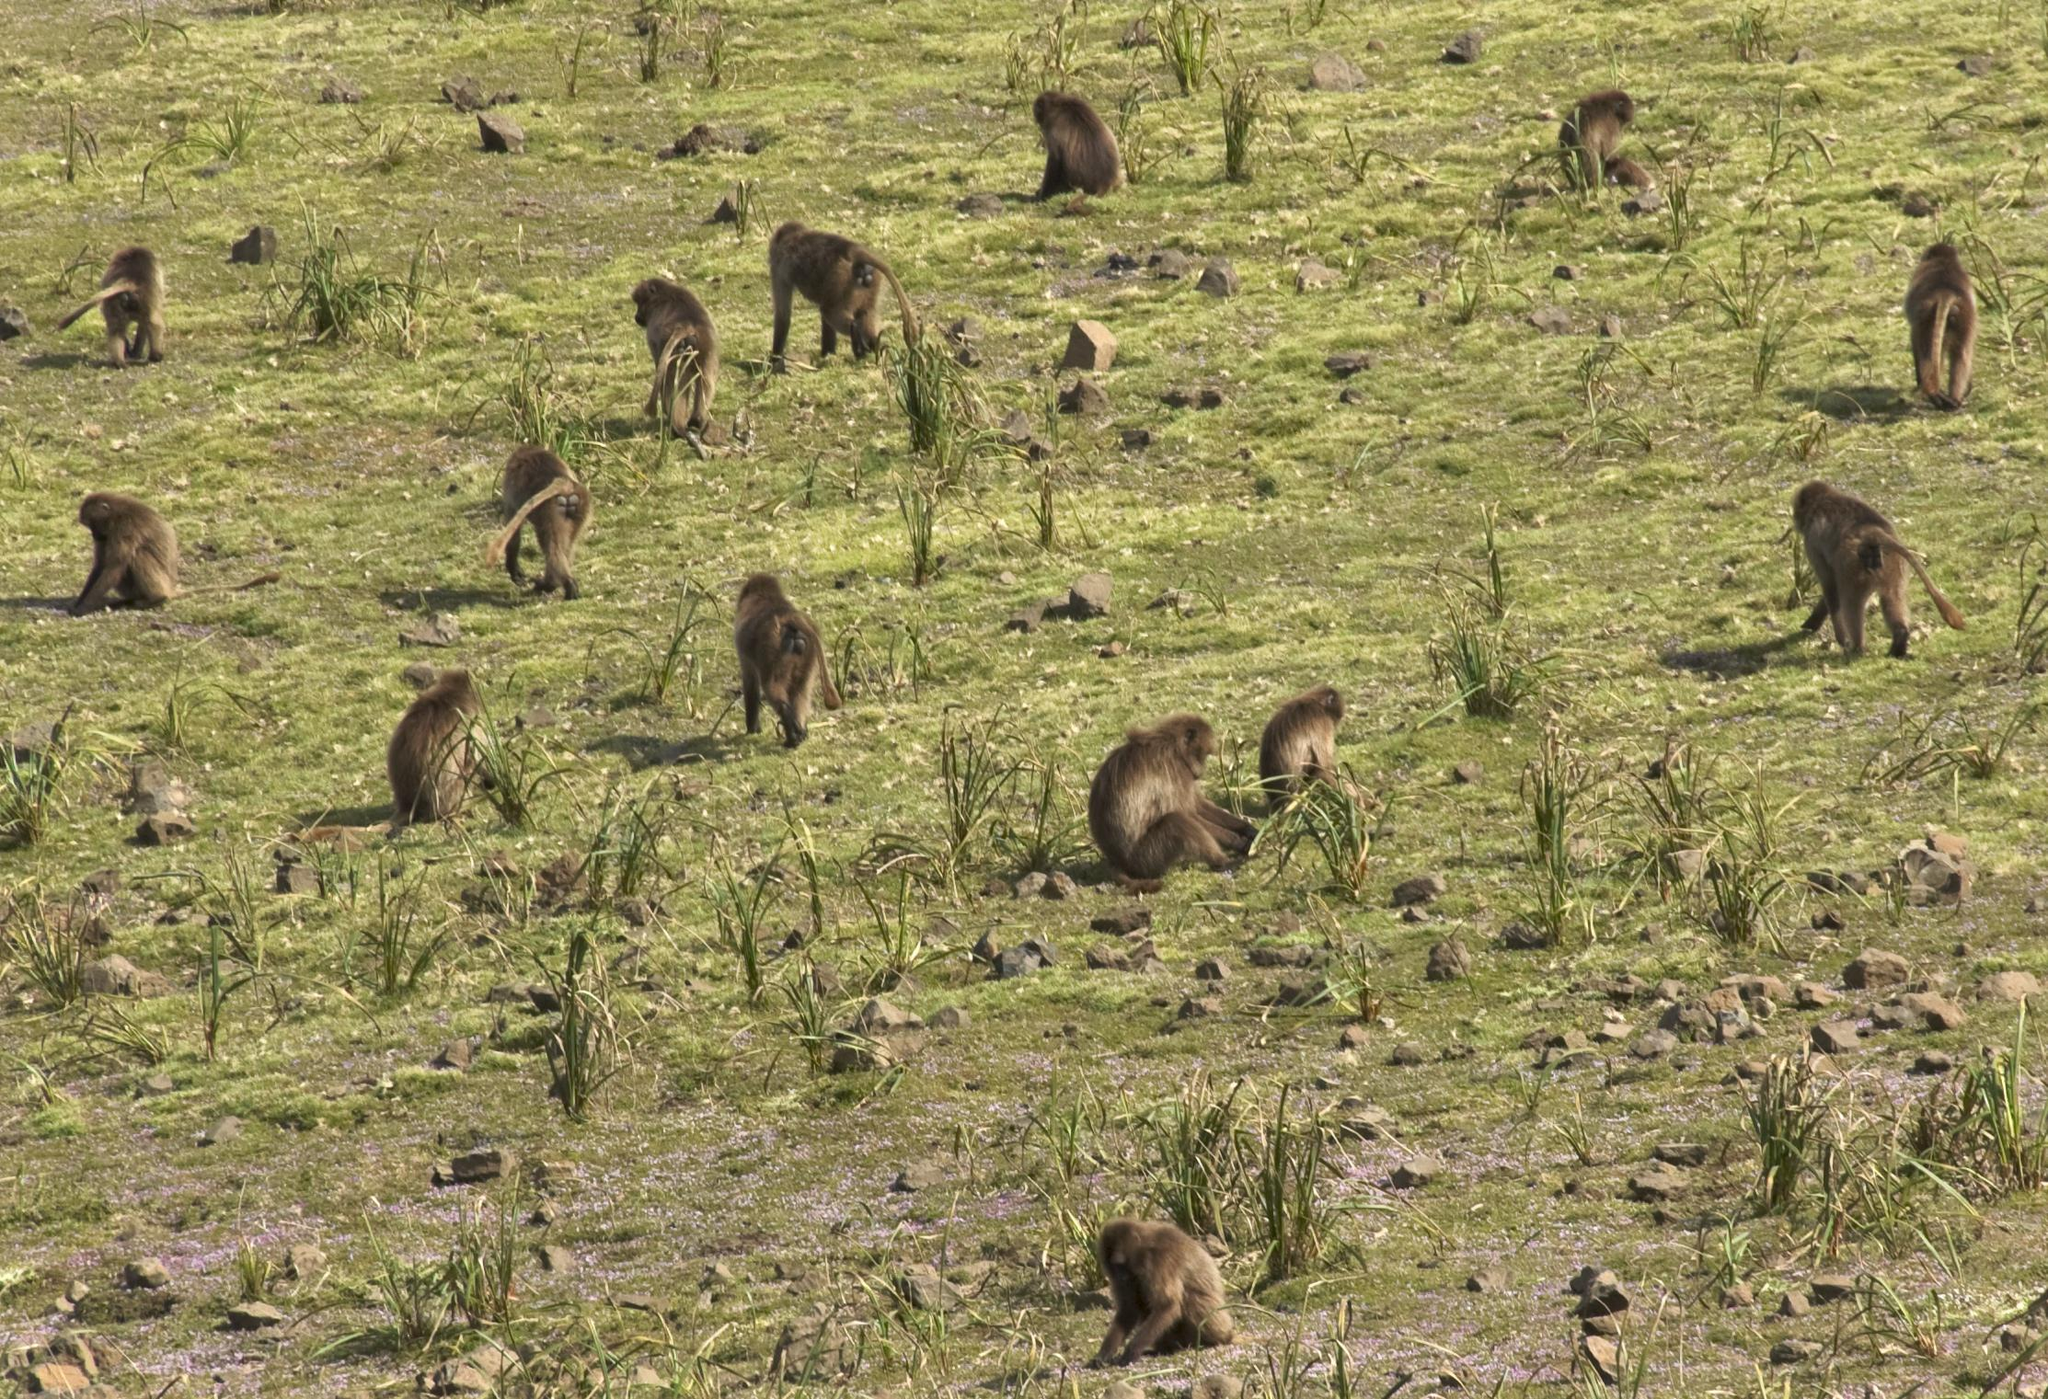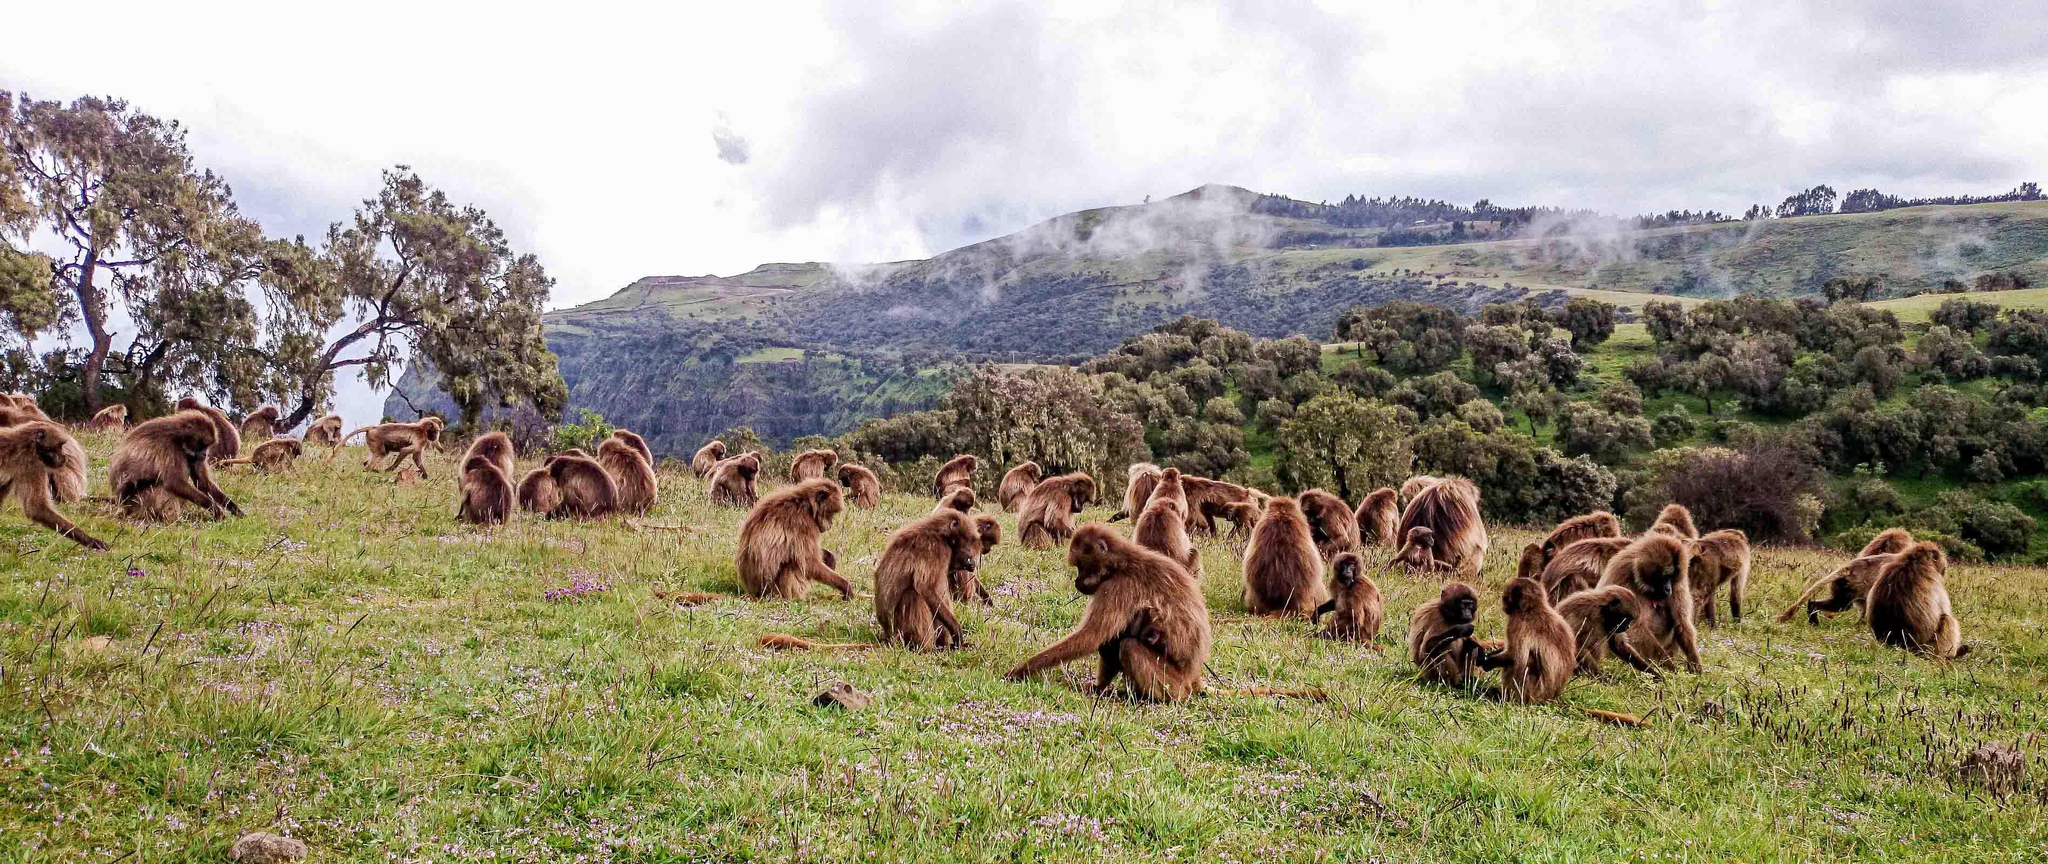The first image is the image on the left, the second image is the image on the right. Considering the images on both sides, is "The left image contains exactly one baboon." valid? Answer yes or no. No. The first image is the image on the left, the second image is the image on the right. Analyze the images presented: Is the assertion "The right image shows monkeys crouching on the grass and reaching toward the ground, with no human in the foreground." valid? Answer yes or no. Yes. 